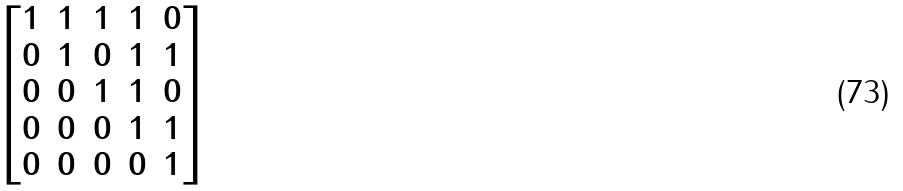<formula> <loc_0><loc_0><loc_500><loc_500>\begin{bmatrix} 1 & 1 & 1 & 1 & 0 \\ 0 & 1 & 0 & 1 & 1 \\ 0 & 0 & 1 & 1 & 0 \\ 0 & 0 & 0 & 1 & 1 \\ 0 & 0 & 0 & 0 & 1 \end{bmatrix}</formula> 